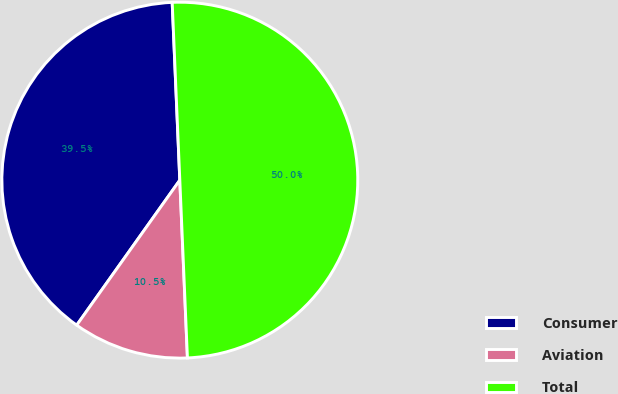<chart> <loc_0><loc_0><loc_500><loc_500><pie_chart><fcel>Consumer<fcel>Aviation<fcel>Total<nl><fcel>39.48%<fcel>10.52%<fcel>50.0%<nl></chart> 